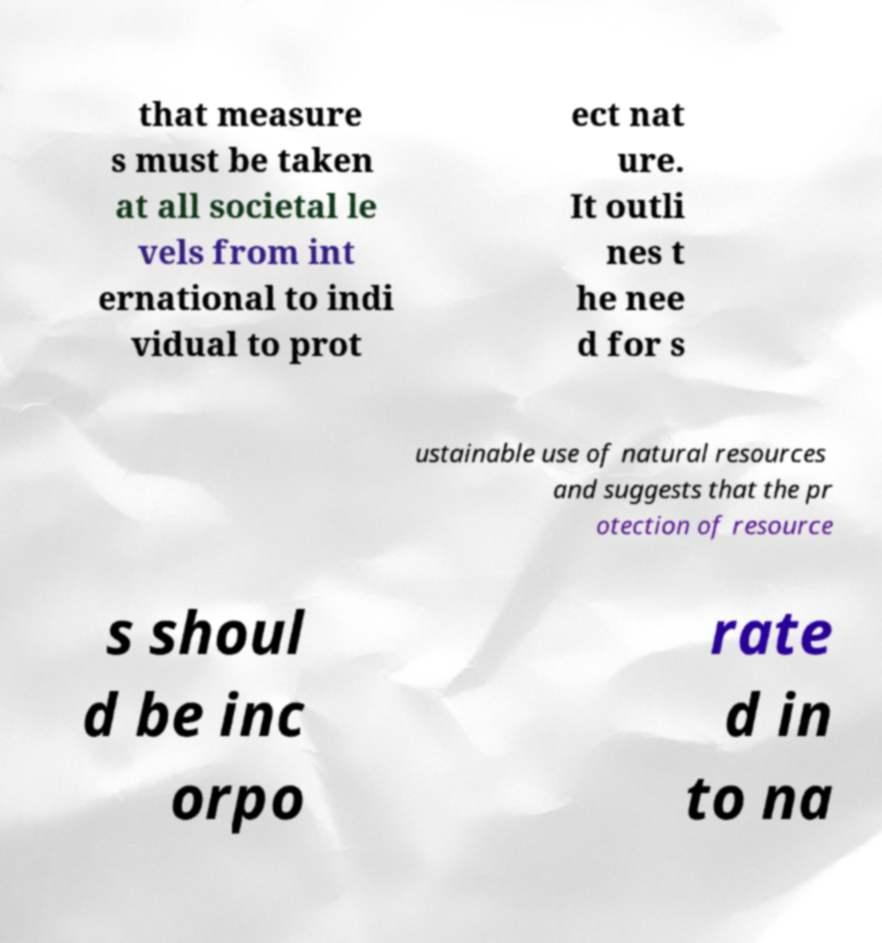Could you assist in decoding the text presented in this image and type it out clearly? that measure s must be taken at all societal le vels from int ernational to indi vidual to prot ect nat ure. It outli nes t he nee d for s ustainable use of natural resources and suggests that the pr otection of resource s shoul d be inc orpo rate d in to na 